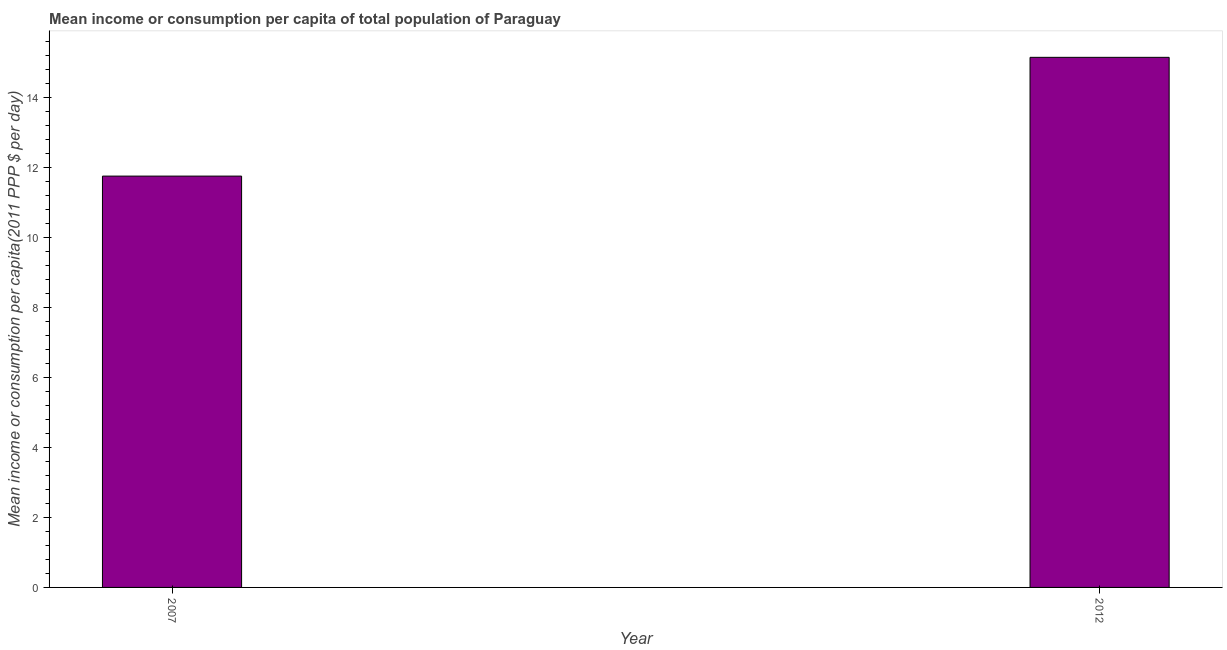Does the graph contain grids?
Keep it short and to the point. No. What is the title of the graph?
Give a very brief answer. Mean income or consumption per capita of total population of Paraguay. What is the label or title of the X-axis?
Your response must be concise. Year. What is the label or title of the Y-axis?
Your answer should be very brief. Mean income or consumption per capita(2011 PPP $ per day). What is the mean income or consumption in 2007?
Provide a succinct answer. 11.75. Across all years, what is the maximum mean income or consumption?
Provide a succinct answer. 15.15. Across all years, what is the minimum mean income or consumption?
Make the answer very short. 11.75. In which year was the mean income or consumption maximum?
Your response must be concise. 2012. What is the sum of the mean income or consumption?
Provide a succinct answer. 26.9. What is the difference between the mean income or consumption in 2007 and 2012?
Your response must be concise. -3.39. What is the average mean income or consumption per year?
Offer a very short reply. 13.45. What is the median mean income or consumption?
Your response must be concise. 13.45. In how many years, is the mean income or consumption greater than 12.4 $?
Keep it short and to the point. 1. Do a majority of the years between 2007 and 2012 (inclusive) have mean income or consumption greater than 5.6 $?
Offer a terse response. Yes. What is the ratio of the mean income or consumption in 2007 to that in 2012?
Keep it short and to the point. 0.78. Is the mean income or consumption in 2007 less than that in 2012?
Offer a terse response. Yes. In how many years, is the mean income or consumption greater than the average mean income or consumption taken over all years?
Offer a terse response. 1. How many bars are there?
Keep it short and to the point. 2. Are all the bars in the graph horizontal?
Your answer should be very brief. No. Are the values on the major ticks of Y-axis written in scientific E-notation?
Ensure brevity in your answer.  No. What is the Mean income or consumption per capita(2011 PPP $ per day) in 2007?
Your answer should be very brief. 11.75. What is the Mean income or consumption per capita(2011 PPP $ per day) of 2012?
Ensure brevity in your answer.  15.15. What is the difference between the Mean income or consumption per capita(2011 PPP $ per day) in 2007 and 2012?
Offer a terse response. -3.39. What is the ratio of the Mean income or consumption per capita(2011 PPP $ per day) in 2007 to that in 2012?
Your answer should be very brief. 0.78. 